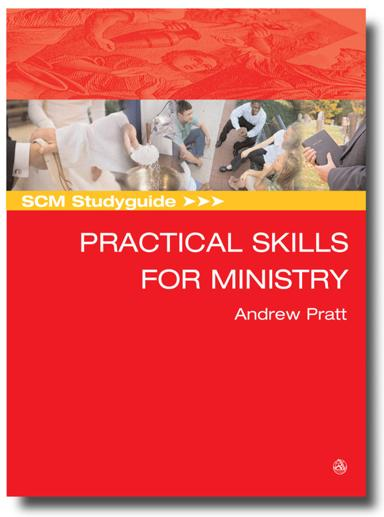Can you describe the visual design of the brochure? The brochure showcases a bold red background that grabs attention, accompanied by a collage of photographic images featuring people in various interactive settings. These visuals imply a focus on practical engagement and human interactions, which are essential in ministry-focused teachings. 